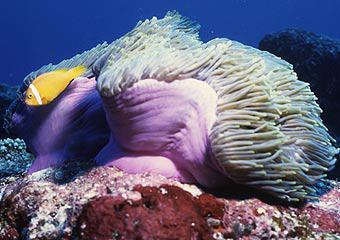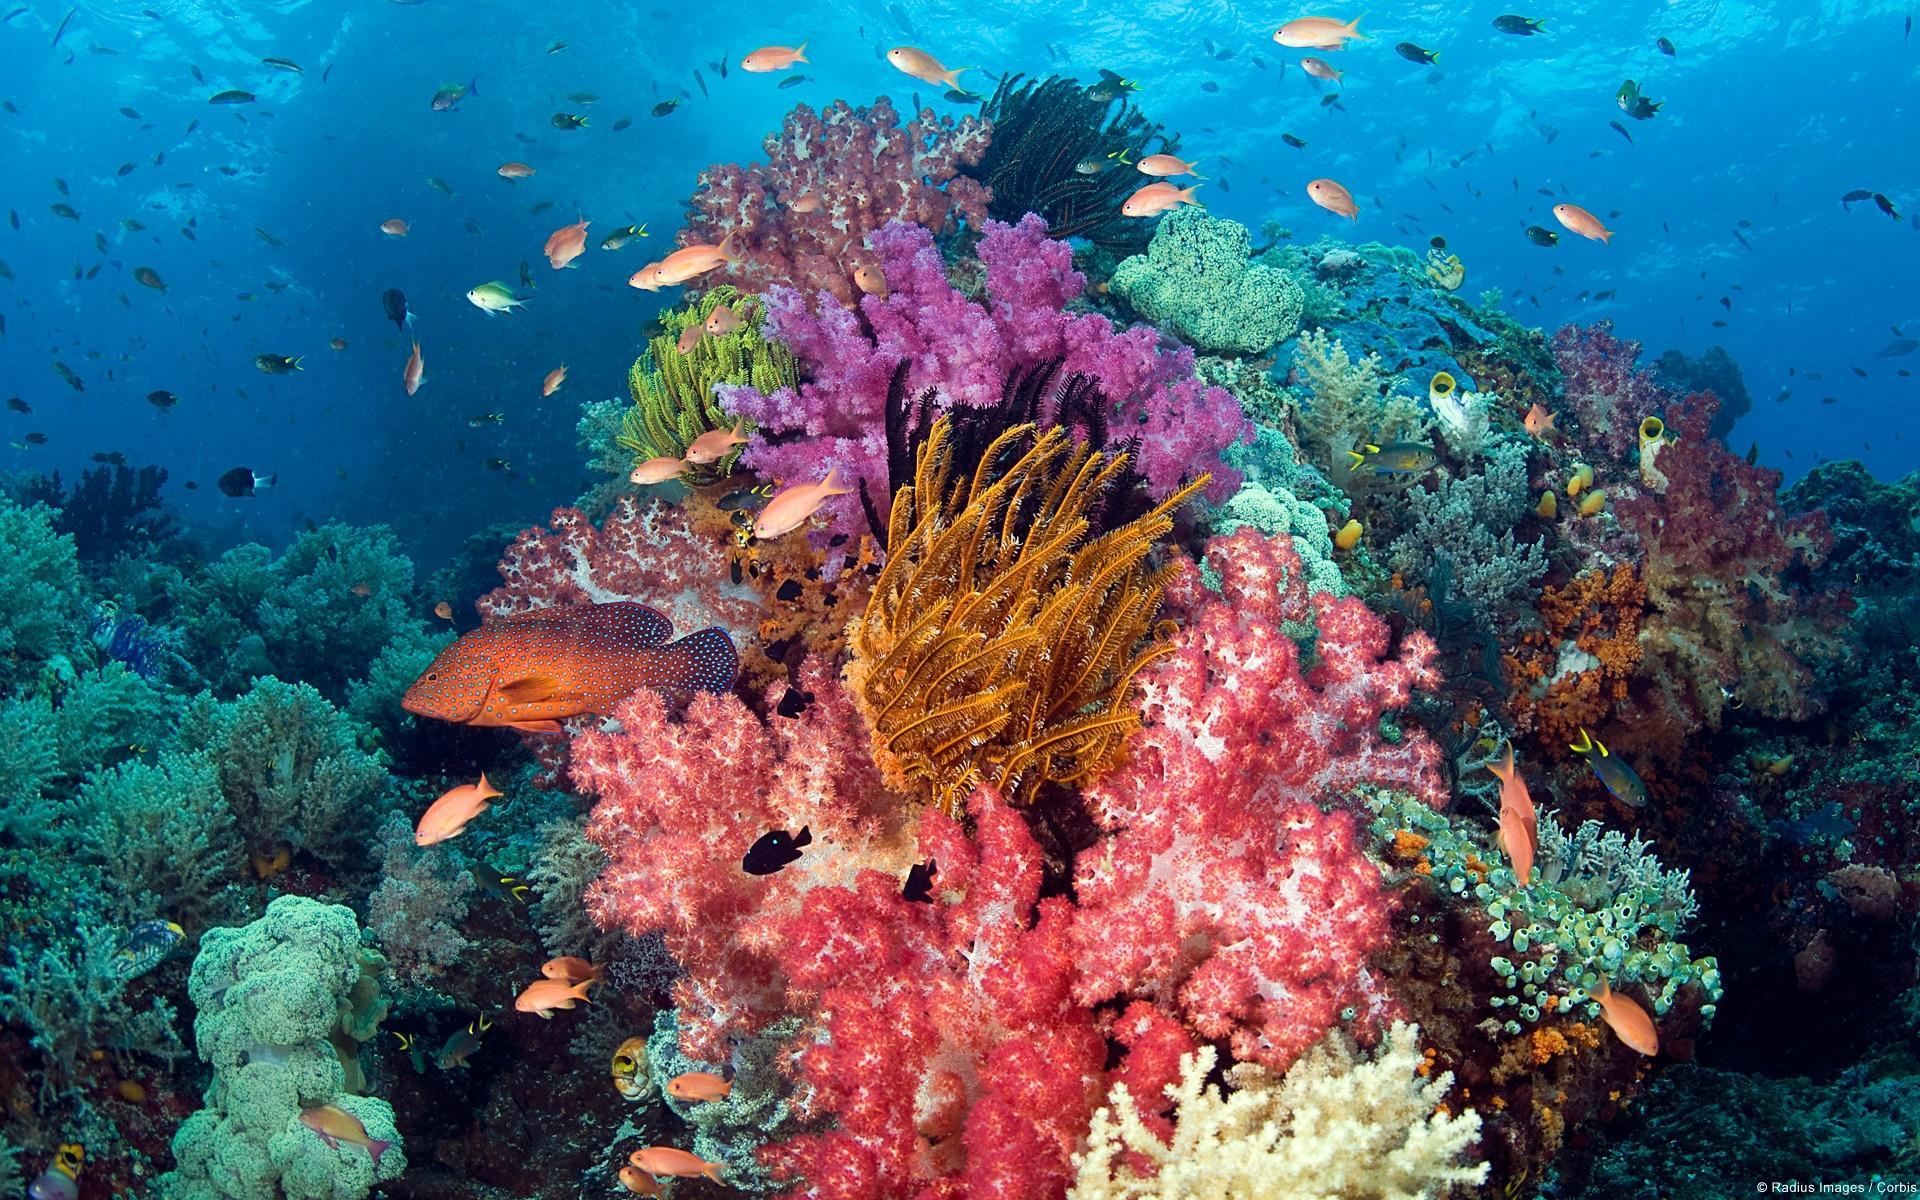The first image is the image on the left, the second image is the image on the right. Assess this claim about the two images: "The left image has at least one fish with a single stripe near it's head swimming near an anemone". Correct or not? Answer yes or no. Yes. 